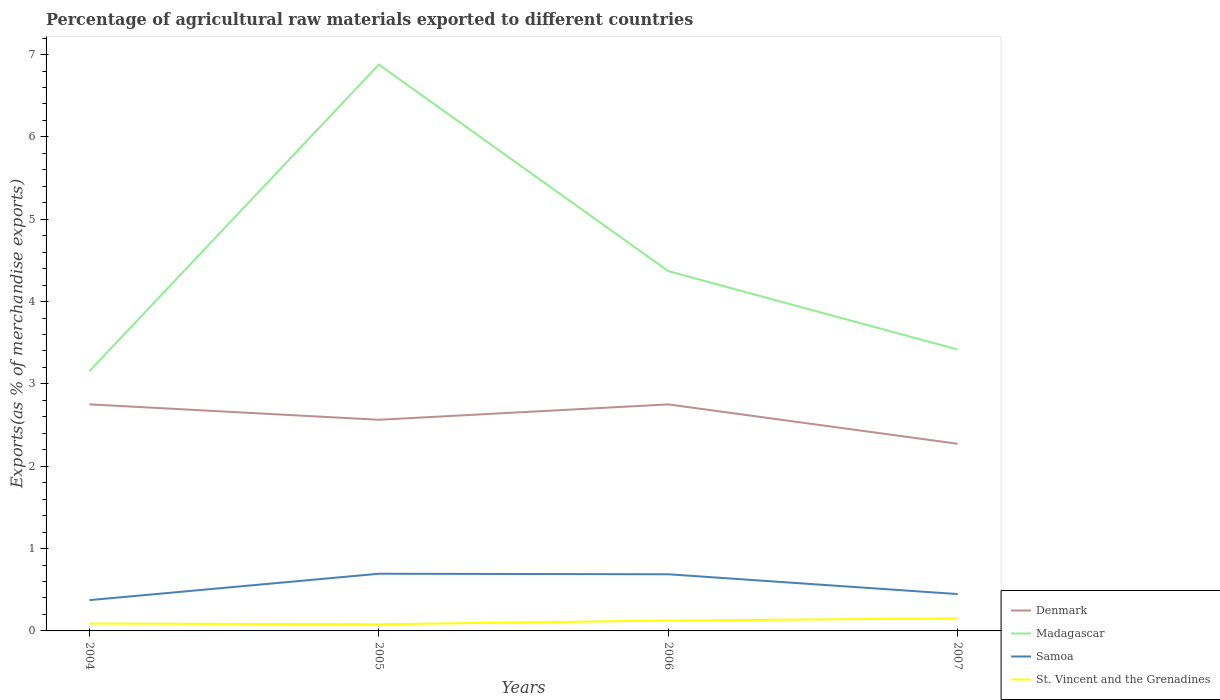Does the line corresponding to St. Vincent and the Grenadines intersect with the line corresponding to Denmark?
Give a very brief answer. No. Across all years, what is the maximum percentage of exports to different countries in Denmark?
Provide a succinct answer. 2.27. In which year was the percentage of exports to different countries in St. Vincent and the Grenadines maximum?
Your answer should be very brief. 2005. What is the total percentage of exports to different countries in Madagascar in the graph?
Your answer should be compact. -0.26. What is the difference between the highest and the second highest percentage of exports to different countries in Denmark?
Offer a very short reply. 0.48. What is the difference between the highest and the lowest percentage of exports to different countries in Madagascar?
Give a very brief answer. 1. How many lines are there?
Keep it short and to the point. 4. Are the values on the major ticks of Y-axis written in scientific E-notation?
Give a very brief answer. No. Does the graph contain any zero values?
Offer a terse response. No. Where does the legend appear in the graph?
Your response must be concise. Bottom right. How are the legend labels stacked?
Provide a short and direct response. Vertical. What is the title of the graph?
Your answer should be compact. Percentage of agricultural raw materials exported to different countries. Does "Ireland" appear as one of the legend labels in the graph?
Your response must be concise. No. What is the label or title of the Y-axis?
Provide a short and direct response. Exports(as % of merchandise exports). What is the Exports(as % of merchandise exports) of Denmark in 2004?
Your answer should be very brief. 2.75. What is the Exports(as % of merchandise exports) in Madagascar in 2004?
Provide a succinct answer. 3.16. What is the Exports(as % of merchandise exports) in Samoa in 2004?
Offer a very short reply. 0.37. What is the Exports(as % of merchandise exports) of St. Vincent and the Grenadines in 2004?
Ensure brevity in your answer.  0.09. What is the Exports(as % of merchandise exports) in Denmark in 2005?
Ensure brevity in your answer.  2.56. What is the Exports(as % of merchandise exports) of Madagascar in 2005?
Your response must be concise. 6.88. What is the Exports(as % of merchandise exports) of Samoa in 2005?
Your response must be concise. 0.69. What is the Exports(as % of merchandise exports) in St. Vincent and the Grenadines in 2005?
Your answer should be very brief. 0.08. What is the Exports(as % of merchandise exports) of Denmark in 2006?
Offer a very short reply. 2.75. What is the Exports(as % of merchandise exports) in Madagascar in 2006?
Offer a terse response. 4.37. What is the Exports(as % of merchandise exports) of Samoa in 2006?
Offer a very short reply. 0.69. What is the Exports(as % of merchandise exports) of St. Vincent and the Grenadines in 2006?
Your answer should be compact. 0.13. What is the Exports(as % of merchandise exports) of Denmark in 2007?
Offer a terse response. 2.27. What is the Exports(as % of merchandise exports) of Madagascar in 2007?
Make the answer very short. 3.42. What is the Exports(as % of merchandise exports) of Samoa in 2007?
Make the answer very short. 0.45. What is the Exports(as % of merchandise exports) in St. Vincent and the Grenadines in 2007?
Your answer should be very brief. 0.15. Across all years, what is the maximum Exports(as % of merchandise exports) in Denmark?
Keep it short and to the point. 2.75. Across all years, what is the maximum Exports(as % of merchandise exports) in Madagascar?
Offer a very short reply. 6.88. Across all years, what is the maximum Exports(as % of merchandise exports) of Samoa?
Ensure brevity in your answer.  0.69. Across all years, what is the maximum Exports(as % of merchandise exports) of St. Vincent and the Grenadines?
Provide a succinct answer. 0.15. Across all years, what is the minimum Exports(as % of merchandise exports) of Denmark?
Offer a terse response. 2.27. Across all years, what is the minimum Exports(as % of merchandise exports) in Madagascar?
Offer a terse response. 3.16. Across all years, what is the minimum Exports(as % of merchandise exports) in Samoa?
Your response must be concise. 0.37. Across all years, what is the minimum Exports(as % of merchandise exports) of St. Vincent and the Grenadines?
Make the answer very short. 0.08. What is the total Exports(as % of merchandise exports) in Denmark in the graph?
Your answer should be compact. 10.34. What is the total Exports(as % of merchandise exports) of Madagascar in the graph?
Provide a succinct answer. 17.82. What is the total Exports(as % of merchandise exports) of Samoa in the graph?
Give a very brief answer. 2.2. What is the total Exports(as % of merchandise exports) of St. Vincent and the Grenadines in the graph?
Provide a short and direct response. 0.45. What is the difference between the Exports(as % of merchandise exports) of Denmark in 2004 and that in 2005?
Offer a very short reply. 0.19. What is the difference between the Exports(as % of merchandise exports) of Madagascar in 2004 and that in 2005?
Make the answer very short. -3.72. What is the difference between the Exports(as % of merchandise exports) in Samoa in 2004 and that in 2005?
Provide a short and direct response. -0.32. What is the difference between the Exports(as % of merchandise exports) in St. Vincent and the Grenadines in 2004 and that in 2005?
Offer a terse response. 0.01. What is the difference between the Exports(as % of merchandise exports) of Denmark in 2004 and that in 2006?
Make the answer very short. 0. What is the difference between the Exports(as % of merchandise exports) in Madagascar in 2004 and that in 2006?
Your response must be concise. -1.21. What is the difference between the Exports(as % of merchandise exports) in Samoa in 2004 and that in 2006?
Your response must be concise. -0.31. What is the difference between the Exports(as % of merchandise exports) of St. Vincent and the Grenadines in 2004 and that in 2006?
Offer a terse response. -0.04. What is the difference between the Exports(as % of merchandise exports) in Denmark in 2004 and that in 2007?
Keep it short and to the point. 0.48. What is the difference between the Exports(as % of merchandise exports) of Madagascar in 2004 and that in 2007?
Ensure brevity in your answer.  -0.26. What is the difference between the Exports(as % of merchandise exports) of Samoa in 2004 and that in 2007?
Your answer should be very brief. -0.07. What is the difference between the Exports(as % of merchandise exports) of St. Vincent and the Grenadines in 2004 and that in 2007?
Offer a terse response. -0.06. What is the difference between the Exports(as % of merchandise exports) in Denmark in 2005 and that in 2006?
Your answer should be very brief. -0.19. What is the difference between the Exports(as % of merchandise exports) of Madagascar in 2005 and that in 2006?
Ensure brevity in your answer.  2.51. What is the difference between the Exports(as % of merchandise exports) of Samoa in 2005 and that in 2006?
Ensure brevity in your answer.  0.01. What is the difference between the Exports(as % of merchandise exports) of St. Vincent and the Grenadines in 2005 and that in 2006?
Your answer should be very brief. -0.05. What is the difference between the Exports(as % of merchandise exports) of Denmark in 2005 and that in 2007?
Keep it short and to the point. 0.29. What is the difference between the Exports(as % of merchandise exports) in Madagascar in 2005 and that in 2007?
Give a very brief answer. 3.46. What is the difference between the Exports(as % of merchandise exports) of Samoa in 2005 and that in 2007?
Keep it short and to the point. 0.25. What is the difference between the Exports(as % of merchandise exports) in St. Vincent and the Grenadines in 2005 and that in 2007?
Offer a very short reply. -0.07. What is the difference between the Exports(as % of merchandise exports) of Denmark in 2006 and that in 2007?
Ensure brevity in your answer.  0.48. What is the difference between the Exports(as % of merchandise exports) of Madagascar in 2006 and that in 2007?
Ensure brevity in your answer.  0.95. What is the difference between the Exports(as % of merchandise exports) of Samoa in 2006 and that in 2007?
Provide a short and direct response. 0.24. What is the difference between the Exports(as % of merchandise exports) of St. Vincent and the Grenadines in 2006 and that in 2007?
Make the answer very short. -0.03. What is the difference between the Exports(as % of merchandise exports) in Denmark in 2004 and the Exports(as % of merchandise exports) in Madagascar in 2005?
Offer a very short reply. -4.13. What is the difference between the Exports(as % of merchandise exports) in Denmark in 2004 and the Exports(as % of merchandise exports) in Samoa in 2005?
Provide a short and direct response. 2.06. What is the difference between the Exports(as % of merchandise exports) in Denmark in 2004 and the Exports(as % of merchandise exports) in St. Vincent and the Grenadines in 2005?
Your answer should be very brief. 2.67. What is the difference between the Exports(as % of merchandise exports) of Madagascar in 2004 and the Exports(as % of merchandise exports) of Samoa in 2005?
Keep it short and to the point. 2.46. What is the difference between the Exports(as % of merchandise exports) in Madagascar in 2004 and the Exports(as % of merchandise exports) in St. Vincent and the Grenadines in 2005?
Give a very brief answer. 3.07. What is the difference between the Exports(as % of merchandise exports) in Samoa in 2004 and the Exports(as % of merchandise exports) in St. Vincent and the Grenadines in 2005?
Your answer should be compact. 0.29. What is the difference between the Exports(as % of merchandise exports) in Denmark in 2004 and the Exports(as % of merchandise exports) in Madagascar in 2006?
Your answer should be compact. -1.62. What is the difference between the Exports(as % of merchandise exports) of Denmark in 2004 and the Exports(as % of merchandise exports) of Samoa in 2006?
Offer a very short reply. 2.06. What is the difference between the Exports(as % of merchandise exports) in Denmark in 2004 and the Exports(as % of merchandise exports) in St. Vincent and the Grenadines in 2006?
Keep it short and to the point. 2.63. What is the difference between the Exports(as % of merchandise exports) of Madagascar in 2004 and the Exports(as % of merchandise exports) of Samoa in 2006?
Offer a very short reply. 2.47. What is the difference between the Exports(as % of merchandise exports) in Madagascar in 2004 and the Exports(as % of merchandise exports) in St. Vincent and the Grenadines in 2006?
Give a very brief answer. 3.03. What is the difference between the Exports(as % of merchandise exports) in Samoa in 2004 and the Exports(as % of merchandise exports) in St. Vincent and the Grenadines in 2006?
Keep it short and to the point. 0.25. What is the difference between the Exports(as % of merchandise exports) in Denmark in 2004 and the Exports(as % of merchandise exports) in Madagascar in 2007?
Make the answer very short. -0.67. What is the difference between the Exports(as % of merchandise exports) in Denmark in 2004 and the Exports(as % of merchandise exports) in Samoa in 2007?
Make the answer very short. 2.3. What is the difference between the Exports(as % of merchandise exports) of Denmark in 2004 and the Exports(as % of merchandise exports) of St. Vincent and the Grenadines in 2007?
Keep it short and to the point. 2.6. What is the difference between the Exports(as % of merchandise exports) of Madagascar in 2004 and the Exports(as % of merchandise exports) of Samoa in 2007?
Ensure brevity in your answer.  2.71. What is the difference between the Exports(as % of merchandise exports) of Madagascar in 2004 and the Exports(as % of merchandise exports) of St. Vincent and the Grenadines in 2007?
Offer a terse response. 3. What is the difference between the Exports(as % of merchandise exports) in Samoa in 2004 and the Exports(as % of merchandise exports) in St. Vincent and the Grenadines in 2007?
Ensure brevity in your answer.  0.22. What is the difference between the Exports(as % of merchandise exports) of Denmark in 2005 and the Exports(as % of merchandise exports) of Madagascar in 2006?
Ensure brevity in your answer.  -1.81. What is the difference between the Exports(as % of merchandise exports) of Denmark in 2005 and the Exports(as % of merchandise exports) of Samoa in 2006?
Your answer should be very brief. 1.88. What is the difference between the Exports(as % of merchandise exports) of Denmark in 2005 and the Exports(as % of merchandise exports) of St. Vincent and the Grenadines in 2006?
Keep it short and to the point. 2.44. What is the difference between the Exports(as % of merchandise exports) of Madagascar in 2005 and the Exports(as % of merchandise exports) of Samoa in 2006?
Your answer should be compact. 6.19. What is the difference between the Exports(as % of merchandise exports) of Madagascar in 2005 and the Exports(as % of merchandise exports) of St. Vincent and the Grenadines in 2006?
Make the answer very short. 6.75. What is the difference between the Exports(as % of merchandise exports) of Samoa in 2005 and the Exports(as % of merchandise exports) of St. Vincent and the Grenadines in 2006?
Your answer should be very brief. 0.57. What is the difference between the Exports(as % of merchandise exports) in Denmark in 2005 and the Exports(as % of merchandise exports) in Madagascar in 2007?
Offer a terse response. -0.85. What is the difference between the Exports(as % of merchandise exports) in Denmark in 2005 and the Exports(as % of merchandise exports) in Samoa in 2007?
Your answer should be very brief. 2.12. What is the difference between the Exports(as % of merchandise exports) in Denmark in 2005 and the Exports(as % of merchandise exports) in St. Vincent and the Grenadines in 2007?
Your response must be concise. 2.41. What is the difference between the Exports(as % of merchandise exports) in Madagascar in 2005 and the Exports(as % of merchandise exports) in Samoa in 2007?
Your answer should be compact. 6.43. What is the difference between the Exports(as % of merchandise exports) in Madagascar in 2005 and the Exports(as % of merchandise exports) in St. Vincent and the Grenadines in 2007?
Provide a short and direct response. 6.73. What is the difference between the Exports(as % of merchandise exports) in Samoa in 2005 and the Exports(as % of merchandise exports) in St. Vincent and the Grenadines in 2007?
Make the answer very short. 0.54. What is the difference between the Exports(as % of merchandise exports) in Denmark in 2006 and the Exports(as % of merchandise exports) in Madagascar in 2007?
Make the answer very short. -0.67. What is the difference between the Exports(as % of merchandise exports) in Denmark in 2006 and the Exports(as % of merchandise exports) in Samoa in 2007?
Provide a succinct answer. 2.3. What is the difference between the Exports(as % of merchandise exports) of Denmark in 2006 and the Exports(as % of merchandise exports) of St. Vincent and the Grenadines in 2007?
Give a very brief answer. 2.6. What is the difference between the Exports(as % of merchandise exports) in Madagascar in 2006 and the Exports(as % of merchandise exports) in Samoa in 2007?
Provide a succinct answer. 3.92. What is the difference between the Exports(as % of merchandise exports) of Madagascar in 2006 and the Exports(as % of merchandise exports) of St. Vincent and the Grenadines in 2007?
Your answer should be very brief. 4.22. What is the difference between the Exports(as % of merchandise exports) in Samoa in 2006 and the Exports(as % of merchandise exports) in St. Vincent and the Grenadines in 2007?
Provide a succinct answer. 0.54. What is the average Exports(as % of merchandise exports) of Denmark per year?
Your answer should be very brief. 2.59. What is the average Exports(as % of merchandise exports) of Madagascar per year?
Offer a terse response. 4.46. What is the average Exports(as % of merchandise exports) in Samoa per year?
Your response must be concise. 0.55. What is the average Exports(as % of merchandise exports) of St. Vincent and the Grenadines per year?
Keep it short and to the point. 0.11. In the year 2004, what is the difference between the Exports(as % of merchandise exports) in Denmark and Exports(as % of merchandise exports) in Madagascar?
Ensure brevity in your answer.  -0.4. In the year 2004, what is the difference between the Exports(as % of merchandise exports) of Denmark and Exports(as % of merchandise exports) of Samoa?
Provide a short and direct response. 2.38. In the year 2004, what is the difference between the Exports(as % of merchandise exports) in Denmark and Exports(as % of merchandise exports) in St. Vincent and the Grenadines?
Give a very brief answer. 2.66. In the year 2004, what is the difference between the Exports(as % of merchandise exports) of Madagascar and Exports(as % of merchandise exports) of Samoa?
Your answer should be compact. 2.78. In the year 2004, what is the difference between the Exports(as % of merchandise exports) of Madagascar and Exports(as % of merchandise exports) of St. Vincent and the Grenadines?
Make the answer very short. 3.07. In the year 2004, what is the difference between the Exports(as % of merchandise exports) of Samoa and Exports(as % of merchandise exports) of St. Vincent and the Grenadines?
Give a very brief answer. 0.28. In the year 2005, what is the difference between the Exports(as % of merchandise exports) of Denmark and Exports(as % of merchandise exports) of Madagascar?
Keep it short and to the point. -4.31. In the year 2005, what is the difference between the Exports(as % of merchandise exports) of Denmark and Exports(as % of merchandise exports) of Samoa?
Make the answer very short. 1.87. In the year 2005, what is the difference between the Exports(as % of merchandise exports) of Denmark and Exports(as % of merchandise exports) of St. Vincent and the Grenadines?
Give a very brief answer. 2.48. In the year 2005, what is the difference between the Exports(as % of merchandise exports) of Madagascar and Exports(as % of merchandise exports) of Samoa?
Your answer should be compact. 6.18. In the year 2005, what is the difference between the Exports(as % of merchandise exports) in Madagascar and Exports(as % of merchandise exports) in St. Vincent and the Grenadines?
Provide a short and direct response. 6.8. In the year 2005, what is the difference between the Exports(as % of merchandise exports) in Samoa and Exports(as % of merchandise exports) in St. Vincent and the Grenadines?
Provide a short and direct response. 0.61. In the year 2006, what is the difference between the Exports(as % of merchandise exports) in Denmark and Exports(as % of merchandise exports) in Madagascar?
Your answer should be compact. -1.62. In the year 2006, what is the difference between the Exports(as % of merchandise exports) in Denmark and Exports(as % of merchandise exports) in Samoa?
Offer a very short reply. 2.06. In the year 2006, what is the difference between the Exports(as % of merchandise exports) in Denmark and Exports(as % of merchandise exports) in St. Vincent and the Grenadines?
Offer a very short reply. 2.63. In the year 2006, what is the difference between the Exports(as % of merchandise exports) of Madagascar and Exports(as % of merchandise exports) of Samoa?
Give a very brief answer. 3.68. In the year 2006, what is the difference between the Exports(as % of merchandise exports) in Madagascar and Exports(as % of merchandise exports) in St. Vincent and the Grenadines?
Your response must be concise. 4.24. In the year 2006, what is the difference between the Exports(as % of merchandise exports) in Samoa and Exports(as % of merchandise exports) in St. Vincent and the Grenadines?
Your answer should be very brief. 0.56. In the year 2007, what is the difference between the Exports(as % of merchandise exports) of Denmark and Exports(as % of merchandise exports) of Madagascar?
Offer a terse response. -1.14. In the year 2007, what is the difference between the Exports(as % of merchandise exports) in Denmark and Exports(as % of merchandise exports) in Samoa?
Your response must be concise. 1.83. In the year 2007, what is the difference between the Exports(as % of merchandise exports) in Denmark and Exports(as % of merchandise exports) in St. Vincent and the Grenadines?
Offer a very short reply. 2.12. In the year 2007, what is the difference between the Exports(as % of merchandise exports) of Madagascar and Exports(as % of merchandise exports) of Samoa?
Make the answer very short. 2.97. In the year 2007, what is the difference between the Exports(as % of merchandise exports) in Madagascar and Exports(as % of merchandise exports) in St. Vincent and the Grenadines?
Ensure brevity in your answer.  3.26. In the year 2007, what is the difference between the Exports(as % of merchandise exports) of Samoa and Exports(as % of merchandise exports) of St. Vincent and the Grenadines?
Your answer should be compact. 0.29. What is the ratio of the Exports(as % of merchandise exports) in Denmark in 2004 to that in 2005?
Your answer should be compact. 1.07. What is the ratio of the Exports(as % of merchandise exports) in Madagascar in 2004 to that in 2005?
Your answer should be very brief. 0.46. What is the ratio of the Exports(as % of merchandise exports) in Samoa in 2004 to that in 2005?
Keep it short and to the point. 0.54. What is the ratio of the Exports(as % of merchandise exports) in St. Vincent and the Grenadines in 2004 to that in 2005?
Offer a terse response. 1.12. What is the ratio of the Exports(as % of merchandise exports) in Madagascar in 2004 to that in 2006?
Your response must be concise. 0.72. What is the ratio of the Exports(as % of merchandise exports) in Samoa in 2004 to that in 2006?
Give a very brief answer. 0.54. What is the ratio of the Exports(as % of merchandise exports) in St. Vincent and the Grenadines in 2004 to that in 2006?
Offer a very short reply. 0.71. What is the ratio of the Exports(as % of merchandise exports) of Denmark in 2004 to that in 2007?
Offer a very short reply. 1.21. What is the ratio of the Exports(as % of merchandise exports) in Madagascar in 2004 to that in 2007?
Ensure brevity in your answer.  0.92. What is the ratio of the Exports(as % of merchandise exports) in Samoa in 2004 to that in 2007?
Offer a very short reply. 0.84. What is the ratio of the Exports(as % of merchandise exports) in St. Vincent and the Grenadines in 2004 to that in 2007?
Your answer should be compact. 0.59. What is the ratio of the Exports(as % of merchandise exports) in Denmark in 2005 to that in 2006?
Make the answer very short. 0.93. What is the ratio of the Exports(as % of merchandise exports) of Madagascar in 2005 to that in 2006?
Ensure brevity in your answer.  1.57. What is the ratio of the Exports(as % of merchandise exports) in Samoa in 2005 to that in 2006?
Ensure brevity in your answer.  1.01. What is the ratio of the Exports(as % of merchandise exports) of St. Vincent and the Grenadines in 2005 to that in 2006?
Provide a short and direct response. 0.64. What is the ratio of the Exports(as % of merchandise exports) of Denmark in 2005 to that in 2007?
Your answer should be compact. 1.13. What is the ratio of the Exports(as % of merchandise exports) of Madagascar in 2005 to that in 2007?
Give a very brief answer. 2.01. What is the ratio of the Exports(as % of merchandise exports) in Samoa in 2005 to that in 2007?
Make the answer very short. 1.55. What is the ratio of the Exports(as % of merchandise exports) in St. Vincent and the Grenadines in 2005 to that in 2007?
Offer a terse response. 0.53. What is the ratio of the Exports(as % of merchandise exports) in Denmark in 2006 to that in 2007?
Your response must be concise. 1.21. What is the ratio of the Exports(as % of merchandise exports) in Madagascar in 2006 to that in 2007?
Make the answer very short. 1.28. What is the ratio of the Exports(as % of merchandise exports) of Samoa in 2006 to that in 2007?
Your response must be concise. 1.54. What is the ratio of the Exports(as % of merchandise exports) in St. Vincent and the Grenadines in 2006 to that in 2007?
Offer a terse response. 0.82. What is the difference between the highest and the second highest Exports(as % of merchandise exports) of Denmark?
Make the answer very short. 0. What is the difference between the highest and the second highest Exports(as % of merchandise exports) in Madagascar?
Your answer should be very brief. 2.51. What is the difference between the highest and the second highest Exports(as % of merchandise exports) of Samoa?
Your response must be concise. 0.01. What is the difference between the highest and the second highest Exports(as % of merchandise exports) in St. Vincent and the Grenadines?
Offer a very short reply. 0.03. What is the difference between the highest and the lowest Exports(as % of merchandise exports) of Denmark?
Offer a very short reply. 0.48. What is the difference between the highest and the lowest Exports(as % of merchandise exports) in Madagascar?
Ensure brevity in your answer.  3.72. What is the difference between the highest and the lowest Exports(as % of merchandise exports) in Samoa?
Offer a terse response. 0.32. What is the difference between the highest and the lowest Exports(as % of merchandise exports) in St. Vincent and the Grenadines?
Ensure brevity in your answer.  0.07. 